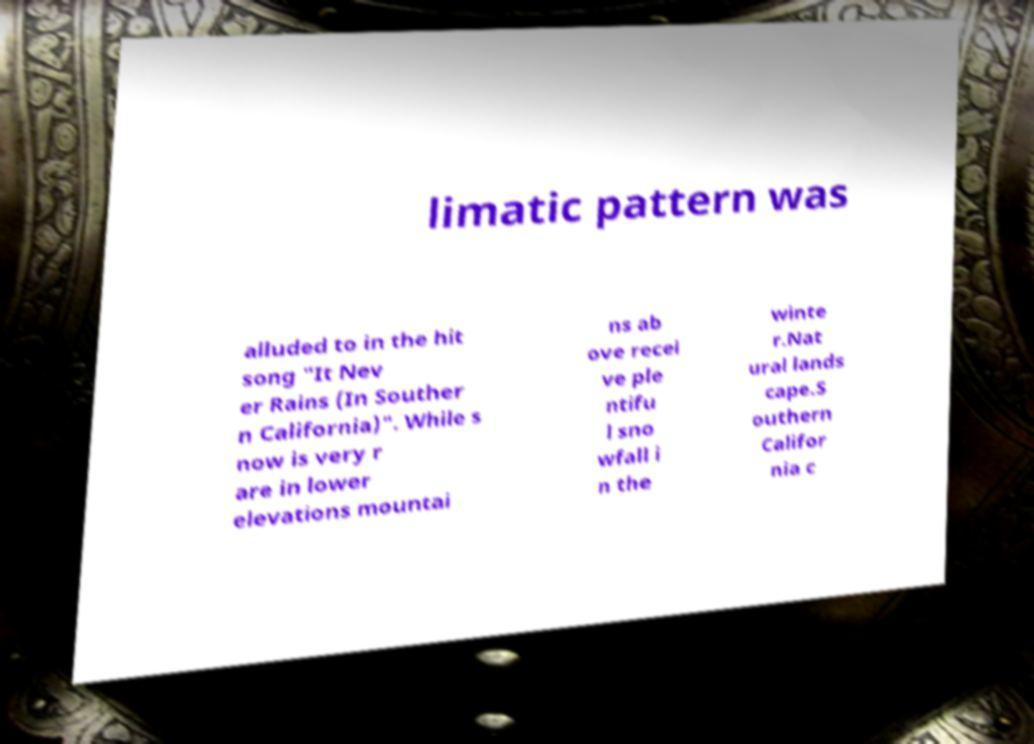Could you assist in decoding the text presented in this image and type it out clearly? limatic pattern was alluded to in the hit song "It Nev er Rains (In Souther n California)". While s now is very r are in lower elevations mountai ns ab ove recei ve ple ntifu l sno wfall i n the winte r.Nat ural lands cape.S outhern Califor nia c 